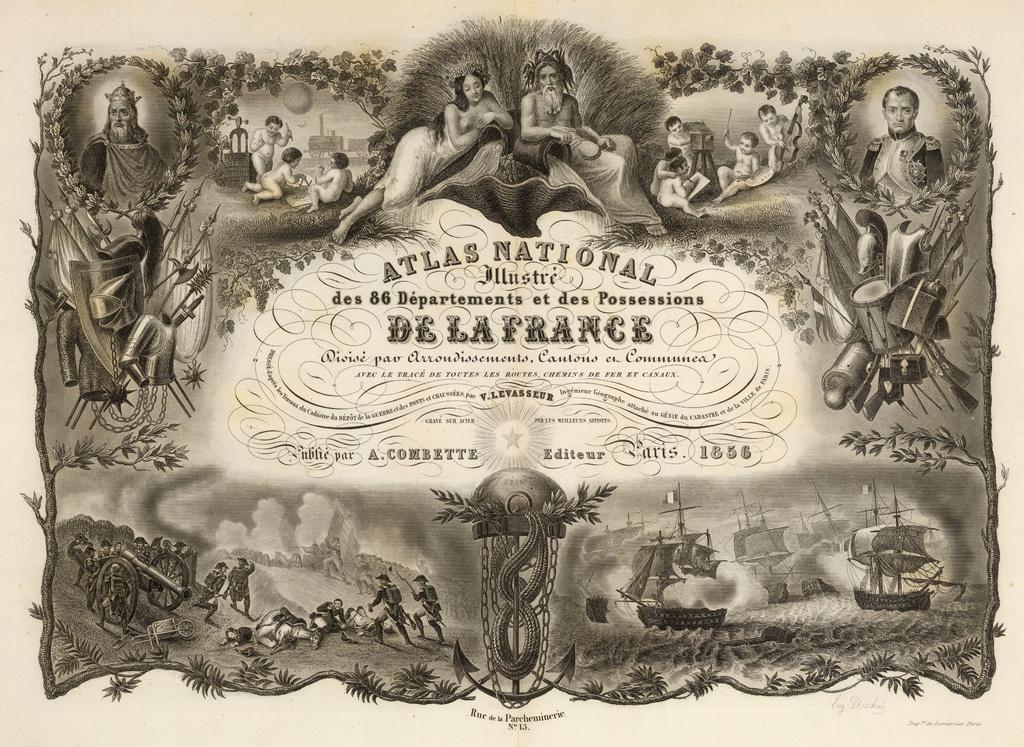Can you describe this image briefly? In this picture I can see a printed image on the paper. I can see few people and few boats on the water and I can see text at the middle of the picture and text at the bottom of the picture. 